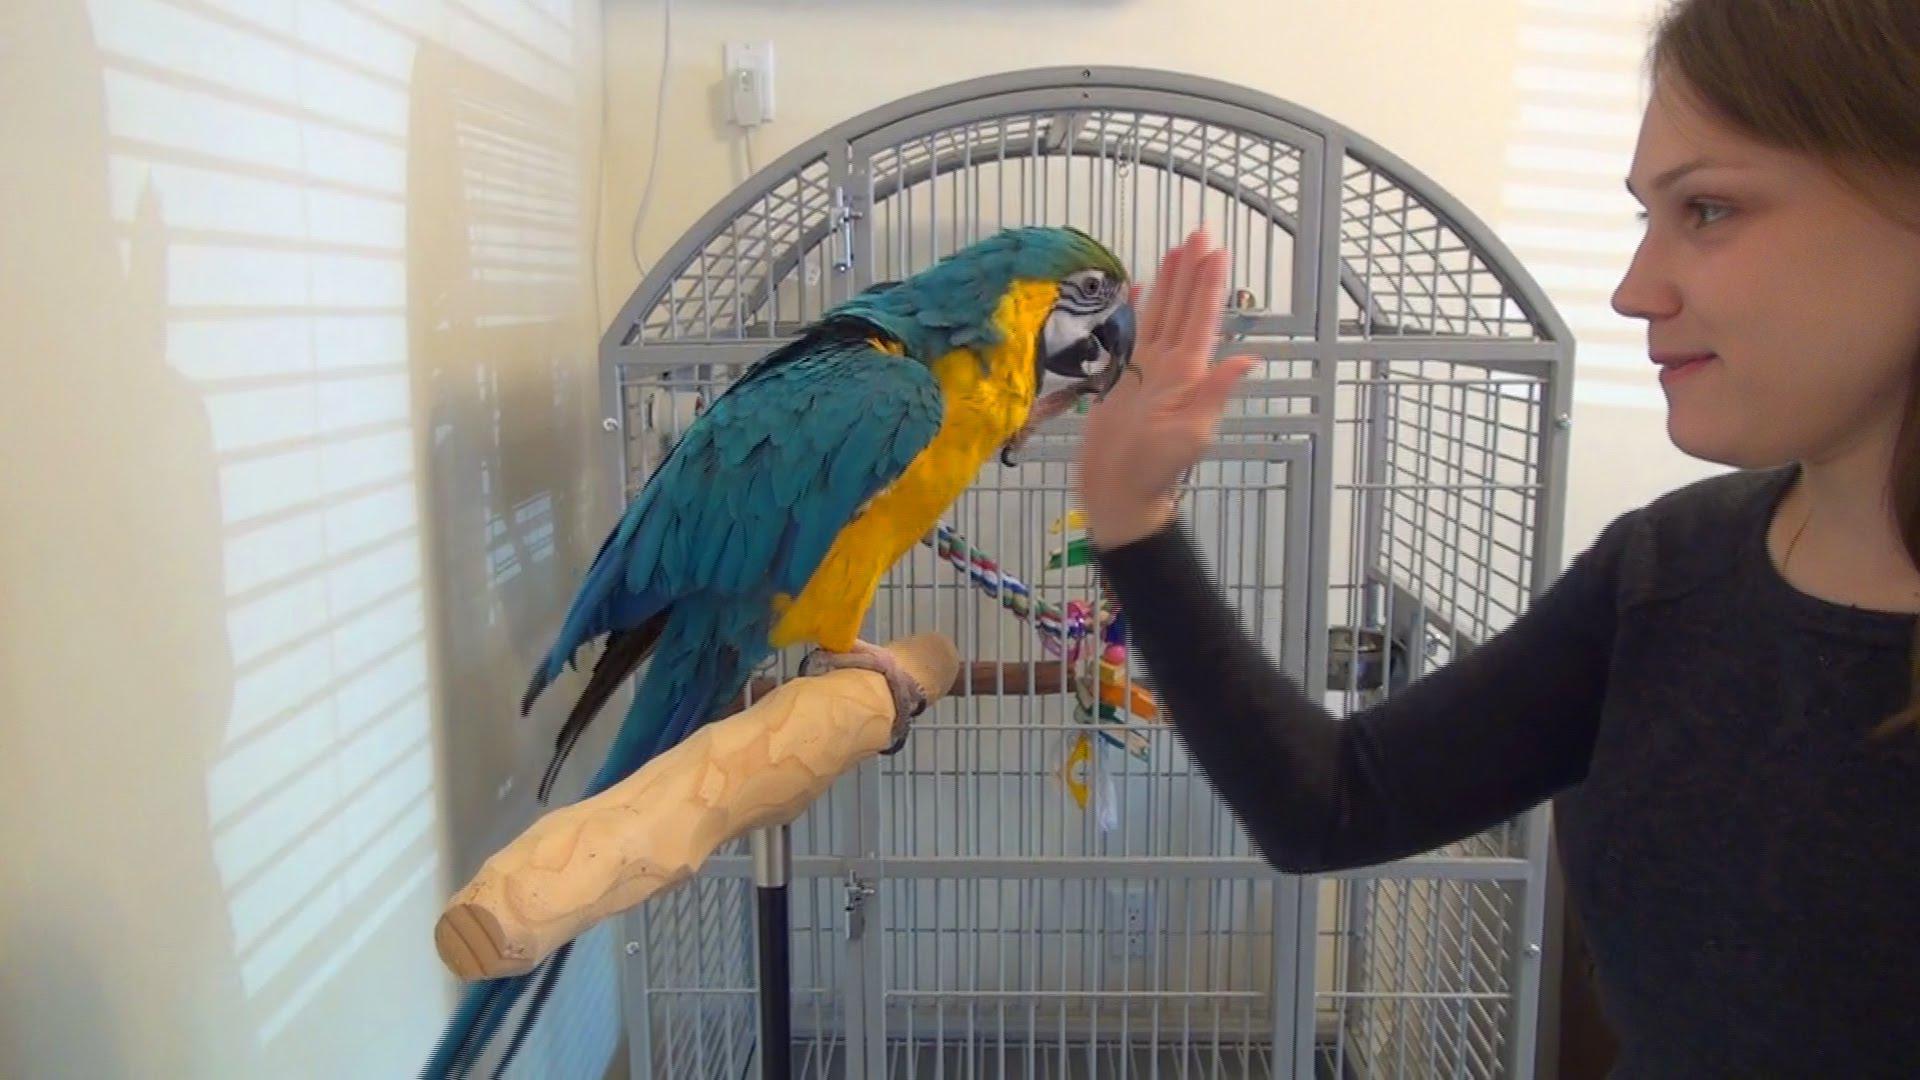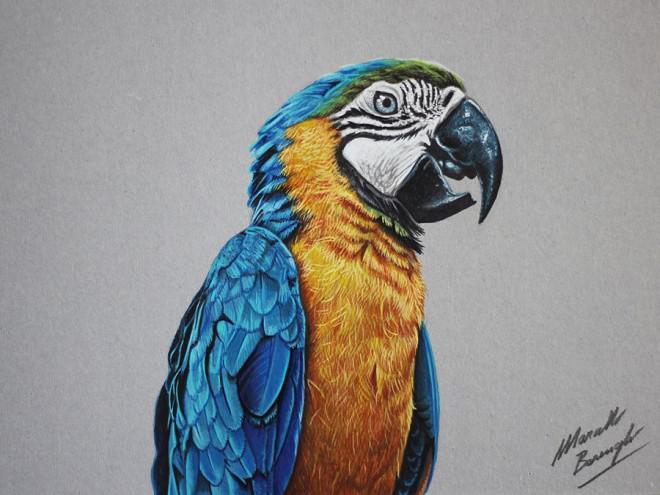The first image is the image on the left, the second image is the image on the right. Examine the images to the left and right. Is the description "One of the humans visible is wearing a long-sleeved shirt." accurate? Answer yes or no. Yes. The first image is the image on the left, the second image is the image on the right. Given the left and right images, does the statement "A person in long dark sleeves holds a hand near the beak of a perching blue-and-yellow parrot, in one image." hold true? Answer yes or no. Yes. 